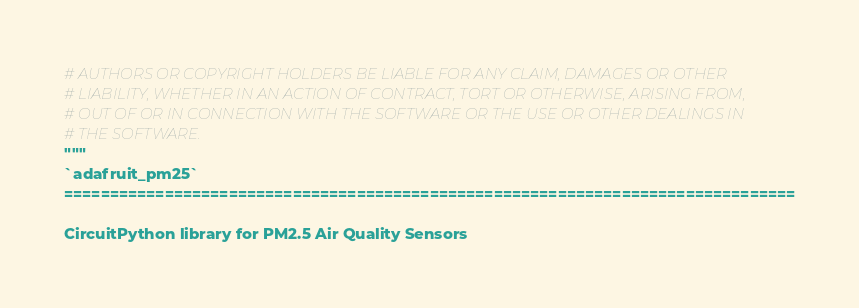<code> <loc_0><loc_0><loc_500><loc_500><_Python_># AUTHORS OR COPYRIGHT HOLDERS BE LIABLE FOR ANY CLAIM, DAMAGES OR OTHER
# LIABILITY, WHETHER IN AN ACTION OF CONTRACT, TORT OR OTHERWISE, ARISING FROM,
# OUT OF OR IN CONNECTION WITH THE SOFTWARE OR THE USE OR OTHER DEALINGS IN
# THE SOFTWARE.
"""
`adafruit_pm25`
================================================================================

CircuitPython library for PM2.5 Air Quality Sensors

</code> 